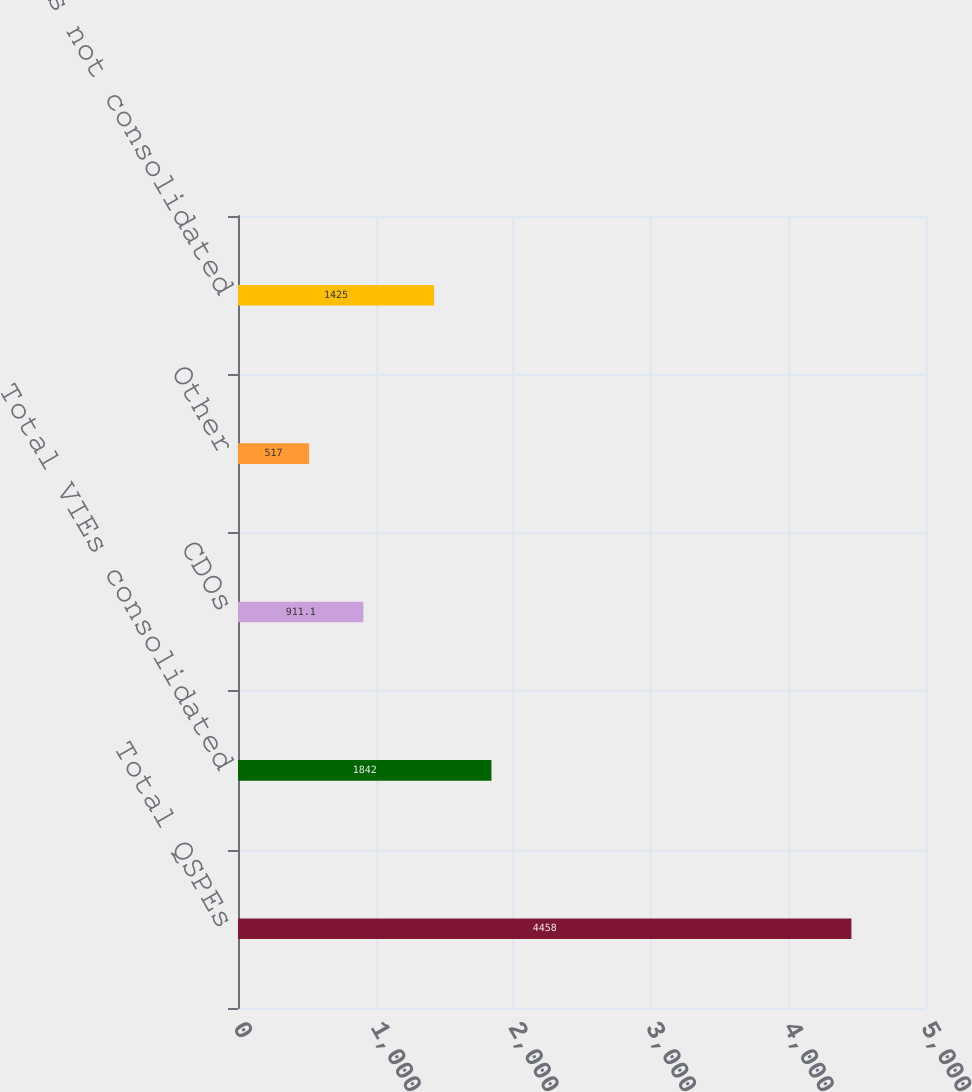Convert chart to OTSL. <chart><loc_0><loc_0><loc_500><loc_500><bar_chart><fcel>Total QSPEs<fcel>Total VIEs consolidated<fcel>CDOs<fcel>Other<fcel>Total VIEs not consolidated<nl><fcel>4458<fcel>1842<fcel>911.1<fcel>517<fcel>1425<nl></chart> 